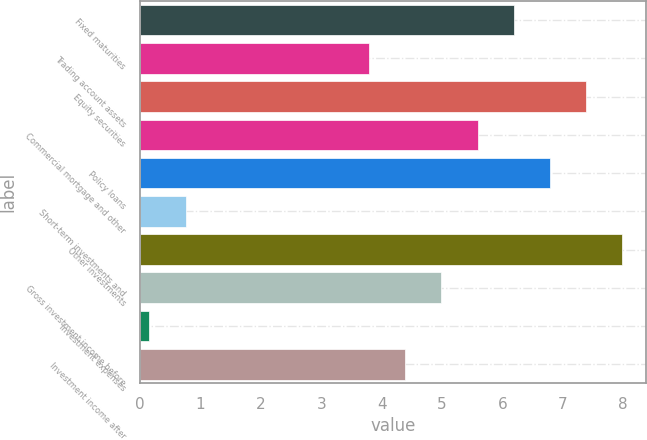Convert chart to OTSL. <chart><loc_0><loc_0><loc_500><loc_500><bar_chart><fcel>Fixed maturities<fcel>Trading account assets<fcel>Equity securities<fcel>Commercial mortgage and other<fcel>Policy loans<fcel>Short-term investments and<fcel>Other investments<fcel>Gross investment income before<fcel>Investment expenses<fcel>Investment income after<nl><fcel>6.19<fcel>3.79<fcel>7.39<fcel>5.59<fcel>6.79<fcel>0.75<fcel>7.99<fcel>4.99<fcel>0.15<fcel>4.39<nl></chart> 